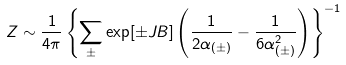Convert formula to latex. <formula><loc_0><loc_0><loc_500><loc_500>Z \sim \frac { 1 } { 4 \pi } \left \{ \sum _ { \pm } \exp [ \pm J B ] \left ( \frac { 1 } { 2 \alpha _ { ( \pm ) } } - \frac { 1 } { 6 \alpha _ { ( \pm ) } ^ { 2 } } \right ) \right \} ^ { - 1 }</formula> 